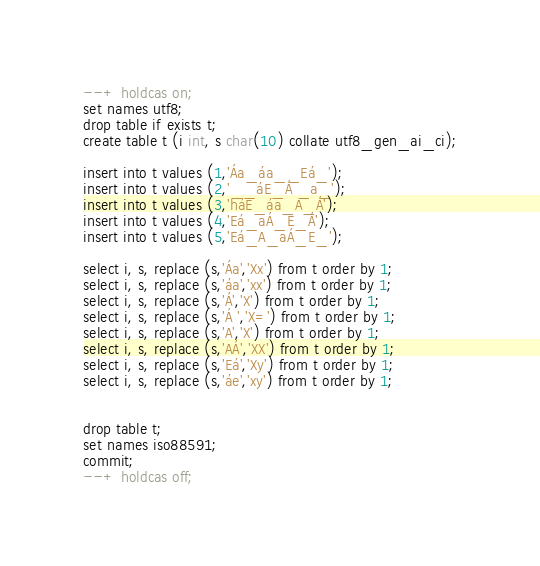Convert code to text. <code><loc_0><loc_0><loc_500><loc_500><_SQL_>--+ holdcas on;
set names utf8;
drop table if exists t;
create table t (i int, s char(10) collate utf8_gen_ai_ci);

insert into t values (1,'Áa_áa__Eá_');
insert into t values (2,'__áE_Á _a_');
insert into t values (3,'háE_áa_A_Á');
insert into t values (4,'Eá_aÁ_E_Á');
insert into t values (5,'Eá_A_aÁ_E_');

select i, s, replace (s,'Áa','Xx') from t order by 1;
select i, s, replace (s,'áa','xx') from t order by 1;
select i, s, replace (s,'Á','X') from t order by 1;
select i, s, replace (s,'Á ','X=') from t order by 1;
select i, s, replace (s,'A','X') from t order by 1;
select i, s, replace (s,'AÁ','XX') from t order by 1;
select i, s, replace (s,'Eá','Xy') from t order by 1;
select i, s, replace (s,'áe','xy') from t order by 1;


drop table t;
set names iso88591;
commit;
--+ holdcas off;
</code> 